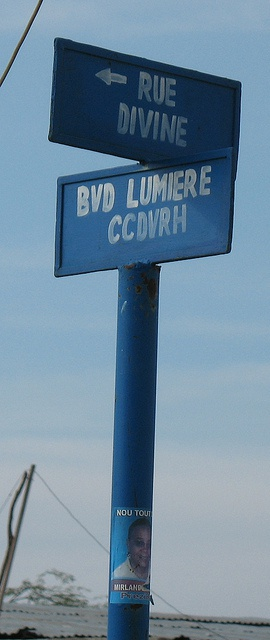Describe the objects in this image and their specific colors. I can see various objects in this image with different colors. 